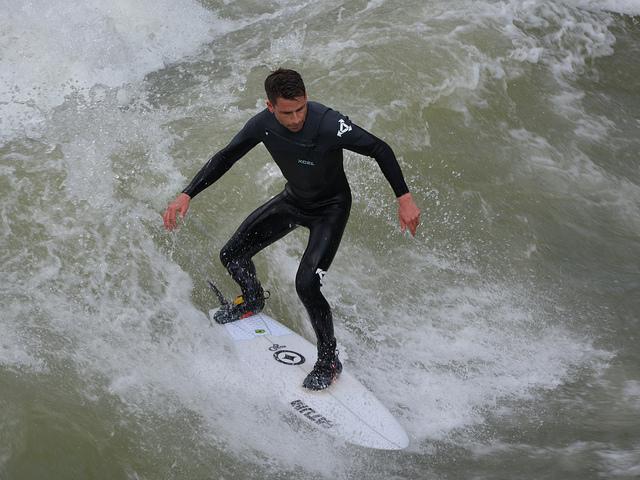Is this man wearing a full length wetsuit?
Write a very short answer. Yes. What is the logo on the man's shirt?
Concise answer only. Ray ban. What is this man wearing to protect himself?
Write a very short answer. Wetsuit. Where is the wetsuit?
Write a very short answer. On man. What is this man doing?
Quick response, please. Surfing. 